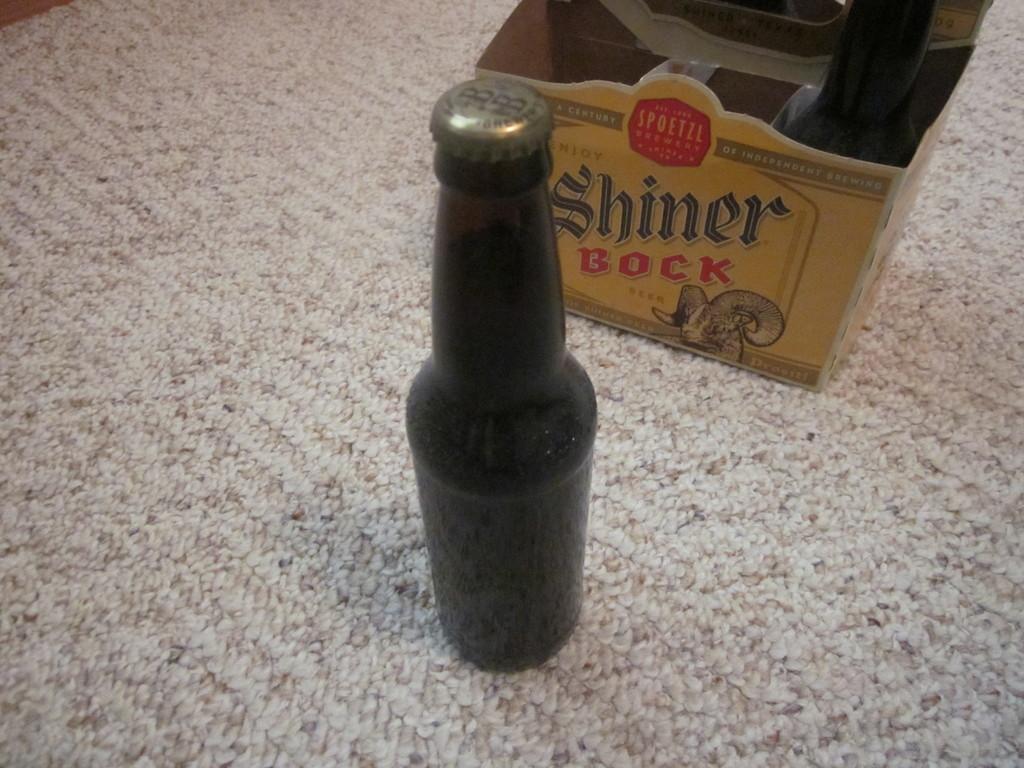What is the name of the beer printed on the box?
Provide a succinct answer. Shiner bock. What color is the beer box?
Give a very brief answer. Answering does not require reading text in the image. 